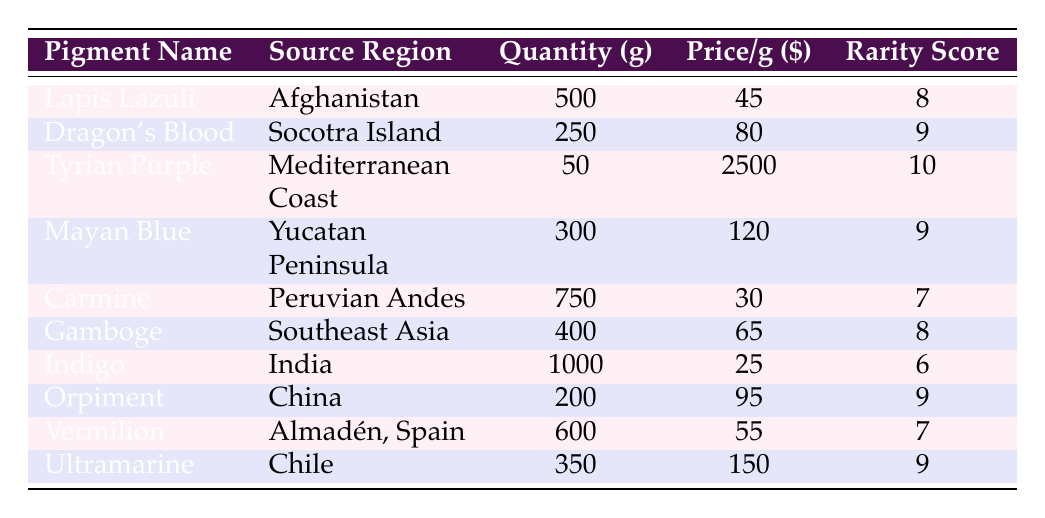What is the price per gram of Tyrian Purple? The table indicates that Tyrian Purple has a price of 2500 dollars per gram. This value is directly stated under the "Price per gram ($)" column for Tyrian Purple.
Answer: 2500 Which pigment has the highest rarity score? The greatest rarity score in the table is 10, which corresponds to Tyrian Purple. This can be easily found by comparing the scores listed under the "Rarity Score" column.
Answer: Tyrian Purple What is the total quantity of pigments sourced from Asia? First, identify the pigments sourced from Asia: Dragon's Blood (250 grams), Gamboge (400 grams), Indigo (1000 grams), and Orpiment (200 grams). Adding these quantities gives 250 + 400 + 1000 + 200 = 1850 grams total.
Answer: 1850 True or false: There are more grams of Carmine than Lapis Lazuli. To compare, Lapis Lazuli has 500 grams and Carmine has 750 grams. Since 750 is greater than 500, the statement is true.
Answer: True What is the average price per gram of the pigments from the Americas? The pigments from the Americas are Lapis Lazuli (45), Mayan Blue (120), Carmine (30), and Ultramarine (150). To find the average, first sum these prices: 45 + 120 + 30 + 150 = 345. Since there are four pigments, divide 345 by 4, giving an average price of 86.25 dollars per gram.
Answer: 86.25 Which pigment has the lowest quantity and what is that quantity? The pigment with the lowest quantity is Tyrian Purple, which has 50 grams. This is easily identified by comparing the quantities in the "Quantity (grams)" column.
Answer: 50 How much more does Dragon's Blood cost per gram than Indigo? The cost of Dragon's Blood per gram is 80 dollars, and the cost of Indigo per gram is 25 dollars. Subtracting the two gives 80 - 25 = 55 dollars.
Answer: 55 Which pigment from China has a rarity score of 9? Based on the table, the pigment from China is Orpiment, which indeed has a rarity score of 9 as observed in the "Rarity Score" column.
Answer: Orpiment 